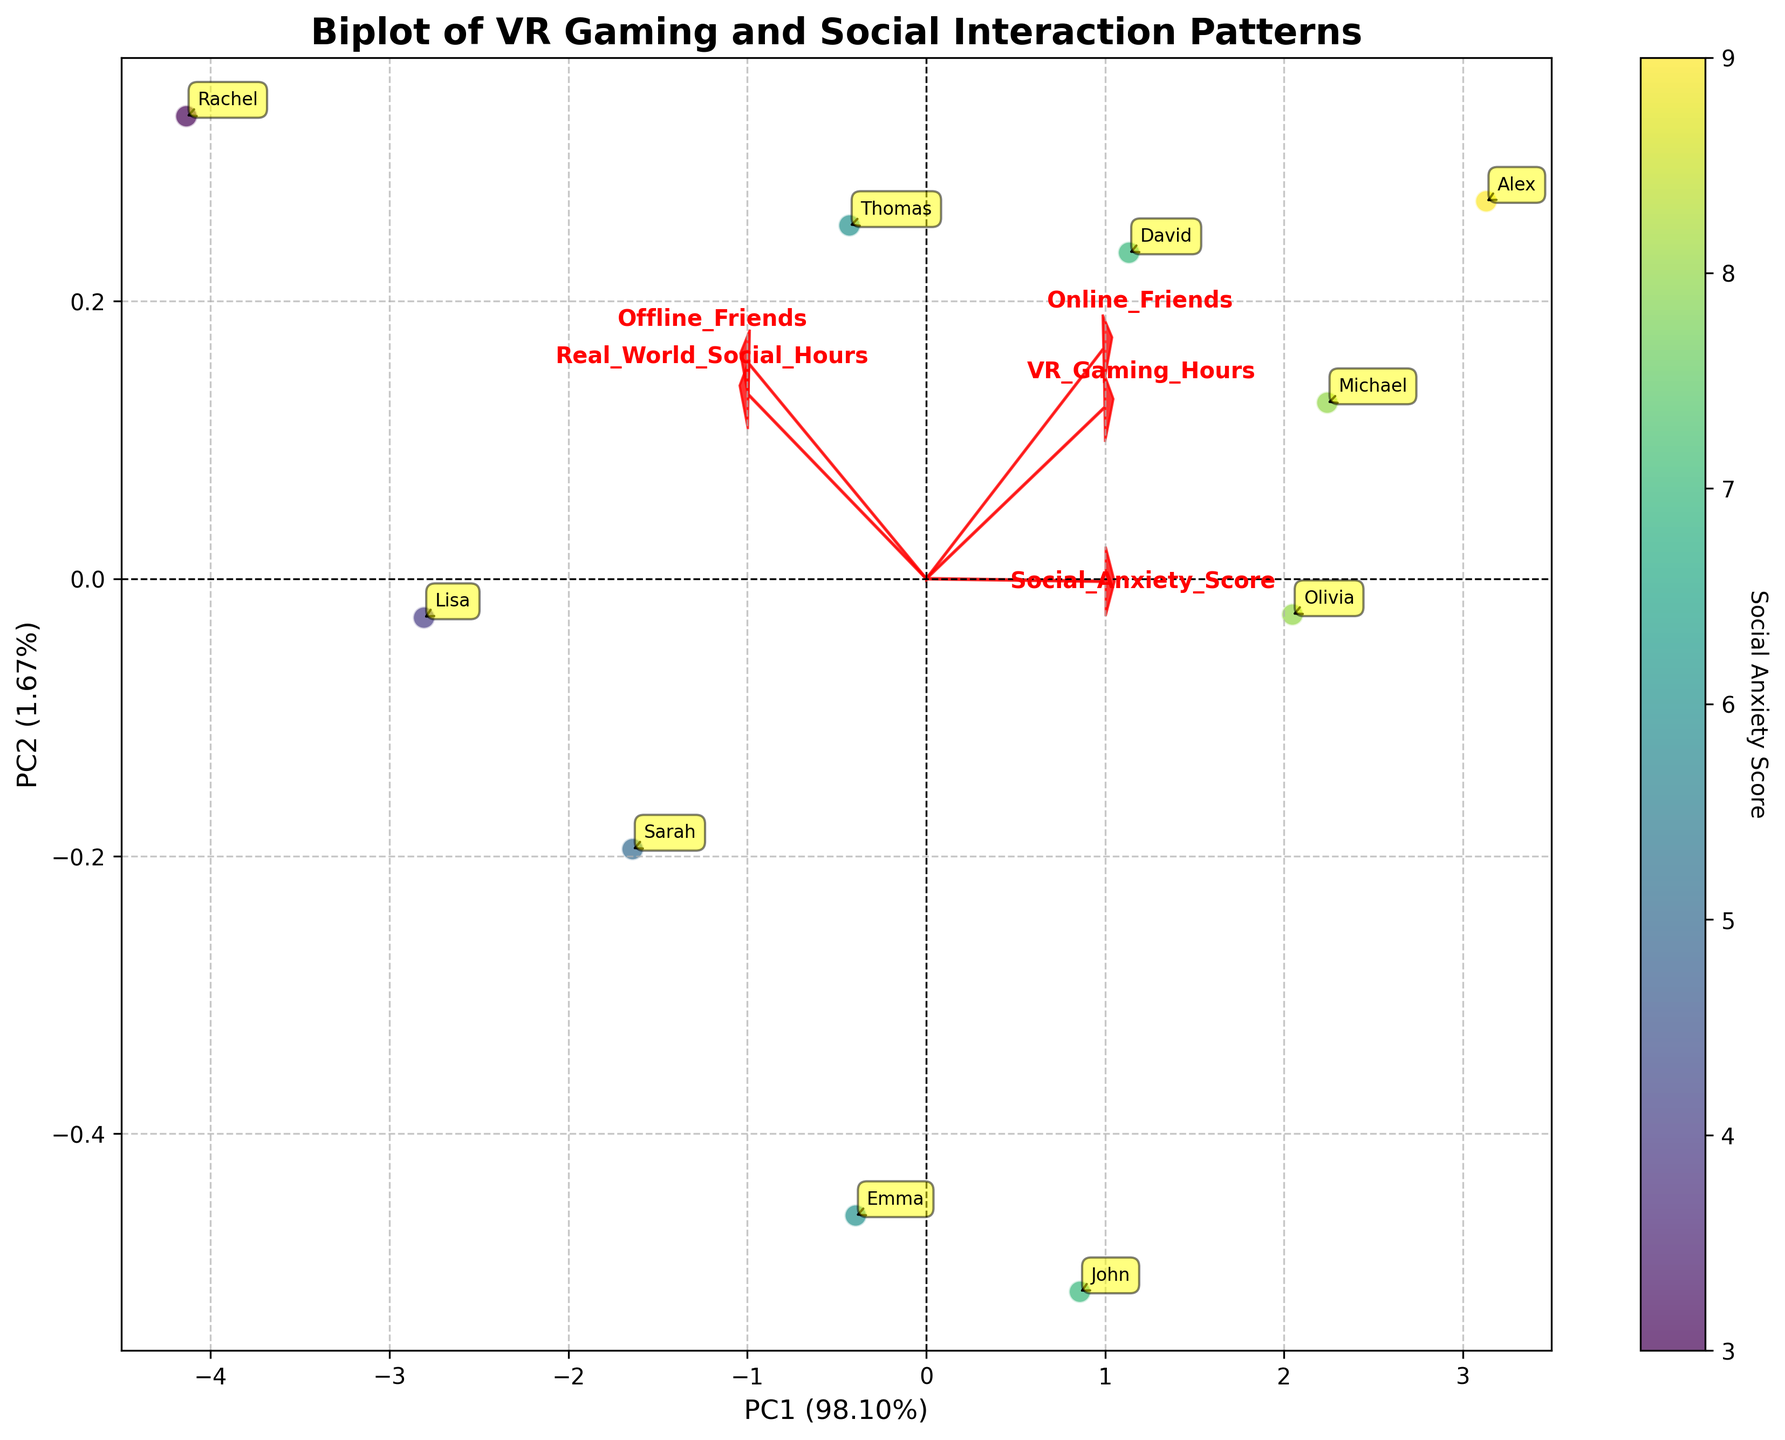What's the title of the figure? The title is usually displayed prominently at the top of the figure. By examining the provided biplot, the title is "Biplot of VR Gaming and Social Interaction Patterns."
Answer: "Biplot of VR Gaming and Social Interaction Patterns" Which feature has the longest arrow in the biplot? In a biplot, the length of the arrow represents the magnitude of the feature. By inspecting the arrows, the "Online_Friends" feature has the longest arrow.
Answer: Online_Friends What percentage of the variance is explained by PC1? The x-axis label of the biplot contains information about the percentage of variance explained by the first principal component (PC1). It shows the value in parentheses. This value is 57%.
Answer: 57% How many data points are there in the biplot? We can count the number of annotated points in the biplot. Each point represents an individual’s data, and there are 10 points annotated with names.
Answer: 10 Which individual has the highest Social Anxiety Score? The color of the points represents the Social Anxiety Score. The darkest points are on the higher end of the color gradient. By inspecting the annotations, Alex, Michael, and Olivia have high scores but Alex's score (9) is the highest.
Answer: Alex How is the feature "Offline_Friends" correlated with "Real_World_Social_Hours"? The arrow direction and length indicate the degree of correlation. "Offline_Friends" and "Real_World_Social_Hours" arrows are pointing in a similar direction, indicating a positive correlation.
Answer: Positively correlated Which individual has spent the most hours in VR gaming? We need to identify the individual represented by the point with the highest value along the "VR_Gaming_Hours" axis. From the annotations, Alex, spending 55 hours, has the highest VR gaming hours.
Answer: Alex Is there a negative correlation between VR Gaming Hours and Real World Social Hours? The direction of the "VR_Gaming_Hours" and "Real_World_Social_Hours" arrows in the biplot helps determine this. Since the arrows point in almost opposite directions, it indicates a negative correlation.
Answer: Yes Compare the number of online friends for John and Rachel. Who has more? John and Rachel are represented by points annotated with their names. The color and position relative to "Online_Friends" axis show John (150) has more online friends than Rachel (60).
Answer: John What component explains the second highest variance? The y-axis label provides information about the second principal component (PC2) and the percentage is shown next to the label. This is the second component after PC1 and PC2 explains 23% of the variance.
Answer: PC2 